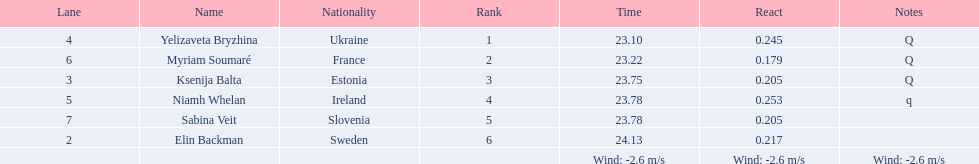Can you parse all the data within this table? {'header': ['Lane', 'Name', 'Nationality', 'Rank', 'Time', 'React', 'Notes'], 'rows': [['4', 'Yelizaveta Bryzhina', 'Ukraine', '1', '23.10', '0.245', 'Q'], ['6', 'Myriam Soumaré', 'France', '2', '23.22', '0.179', 'Q'], ['3', 'Ksenija Balta', 'Estonia', '3', '23.75', '0.205', 'Q'], ['5', 'Niamh Whelan', 'Ireland', '4', '23.78', '0.253', 'q'], ['7', 'Sabina Veit', 'Slovenia', '5', '23.78', '0.205', ''], ['2', 'Elin Backman', 'Sweden', '6', '24.13', '0.217', ''], ['', '', '', '', 'Wind: -2.6\xa0m/s', 'Wind: -2.6\xa0m/s', 'Wind: -2.6\xa0m/s']]} How long did it take elin backman to finish the race? 24.13. 